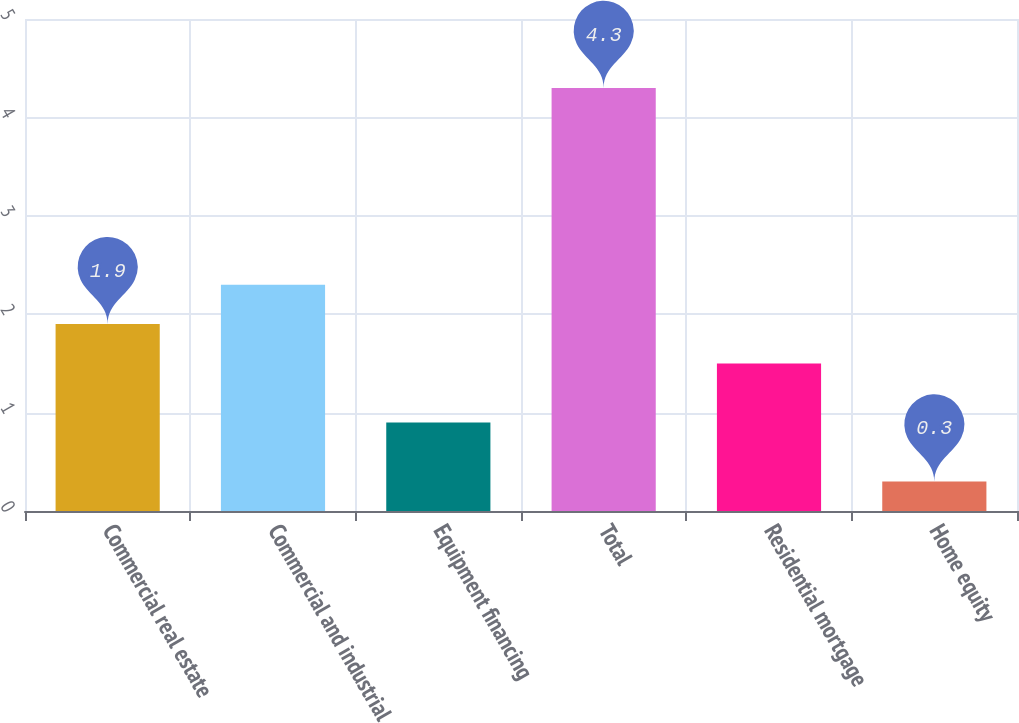Convert chart to OTSL. <chart><loc_0><loc_0><loc_500><loc_500><bar_chart><fcel>Commercial real estate<fcel>Commercial and industrial<fcel>Equipment financing<fcel>Total<fcel>Residential mortgage<fcel>Home equity<nl><fcel>1.9<fcel>2.3<fcel>0.9<fcel>4.3<fcel>1.5<fcel>0.3<nl></chart> 